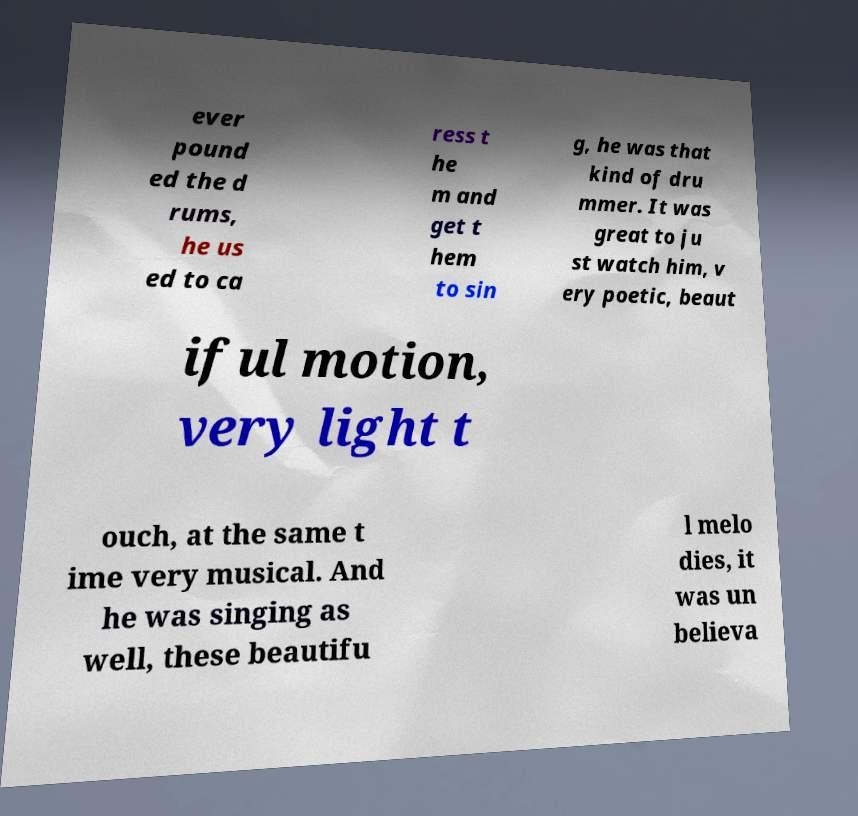Can you accurately transcribe the text from the provided image for me? ever pound ed the d rums, he us ed to ca ress t he m and get t hem to sin g, he was that kind of dru mmer. It was great to ju st watch him, v ery poetic, beaut iful motion, very light t ouch, at the same t ime very musical. And he was singing as well, these beautifu l melo dies, it was un believa 